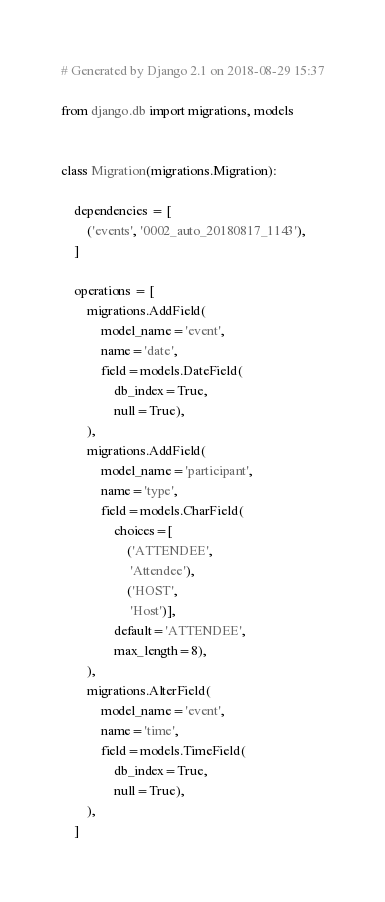Convert code to text. <code><loc_0><loc_0><loc_500><loc_500><_Python_># Generated by Django 2.1 on 2018-08-29 15:37

from django.db import migrations, models


class Migration(migrations.Migration):

    dependencies = [
        ('events', '0002_auto_20180817_1143'),
    ]

    operations = [
        migrations.AddField(
            model_name='event',
            name='date',
            field=models.DateField(
                db_index=True,
                null=True),
        ),
        migrations.AddField(
            model_name='participant',
            name='type',
            field=models.CharField(
                choices=[
                    ('ATTENDEE',
                     'Attendee'),
                    ('HOST',
                     'Host')],
                default='ATTENDEE',
                max_length=8),
        ),
        migrations.AlterField(
            model_name='event',
            name='time',
            field=models.TimeField(
                db_index=True,
                null=True),
        ),
    ]
</code> 